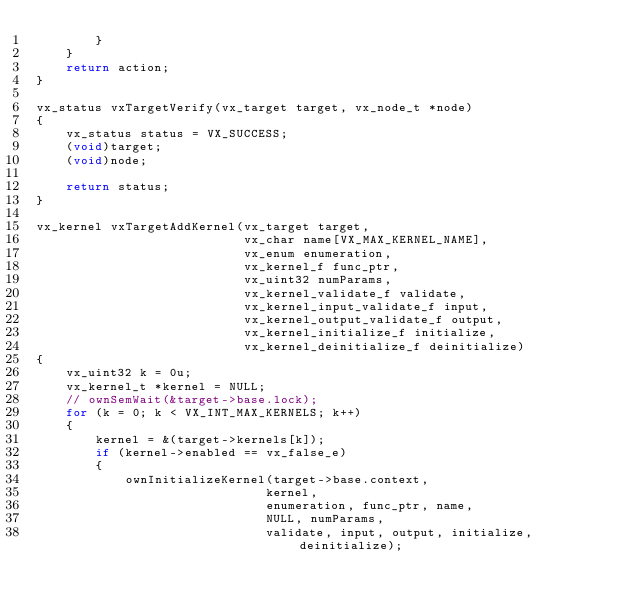Convert code to text. <code><loc_0><loc_0><loc_500><loc_500><_C_>        }
    }
    return action;
}

vx_status vxTargetVerify(vx_target target, vx_node_t *node)
{
    vx_status status = VX_SUCCESS;
    (void)target;
    (void)node;

    return status;
}

vx_kernel vxTargetAddKernel(vx_target target,
                            vx_char name[VX_MAX_KERNEL_NAME],
                            vx_enum enumeration,
                            vx_kernel_f func_ptr,
                            vx_uint32 numParams,
                            vx_kernel_validate_f validate,
                            vx_kernel_input_validate_f input,
                            vx_kernel_output_validate_f output,
                            vx_kernel_initialize_f initialize,
                            vx_kernel_deinitialize_f deinitialize)
{
    vx_uint32 k = 0u;
    vx_kernel_t *kernel = NULL;
    // ownSemWait(&target->base.lock);
    for (k = 0; k < VX_INT_MAX_KERNELS; k++)
    {
        kernel = &(target->kernels[k]);
        if (kernel->enabled == vx_false_e)
        {
            ownInitializeKernel(target->base.context,
                               kernel,
                               enumeration, func_ptr, name,
                               NULL, numParams,
                               validate, input, output, initialize, deinitialize);</code> 